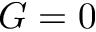<formula> <loc_0><loc_0><loc_500><loc_500>G = 0</formula> 